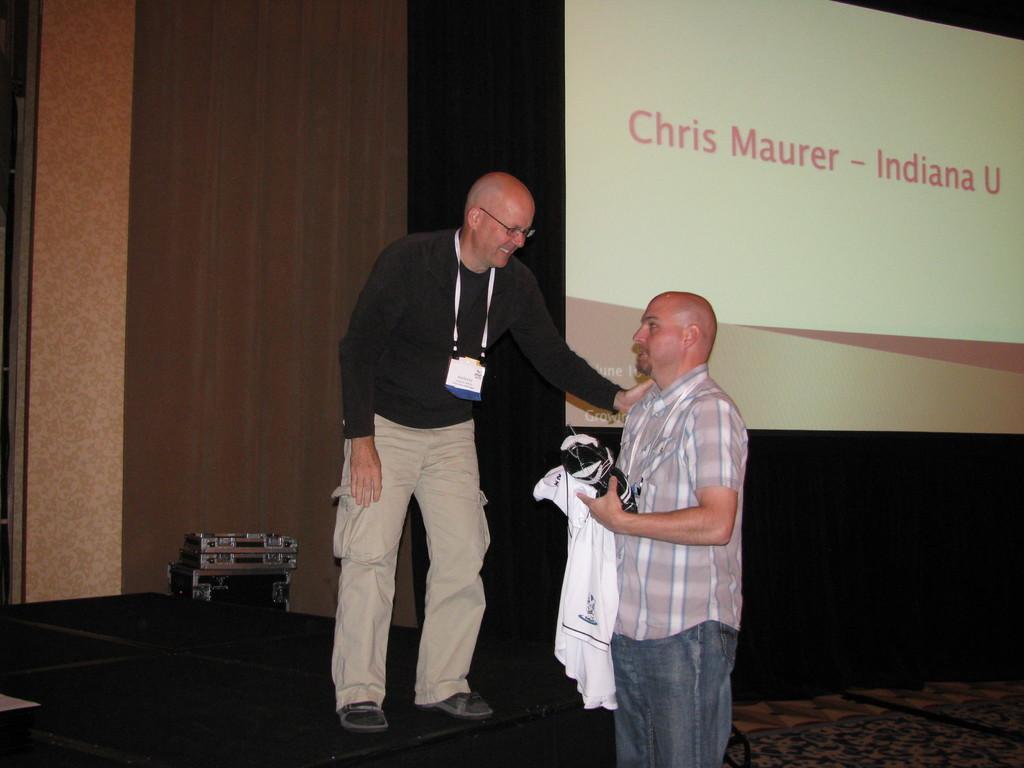How would you summarize this image in a sentence or two? In this image there is a man standing on the stage beside him there is other man standing holding a cloth in hand. Also there is a screen on the top. 